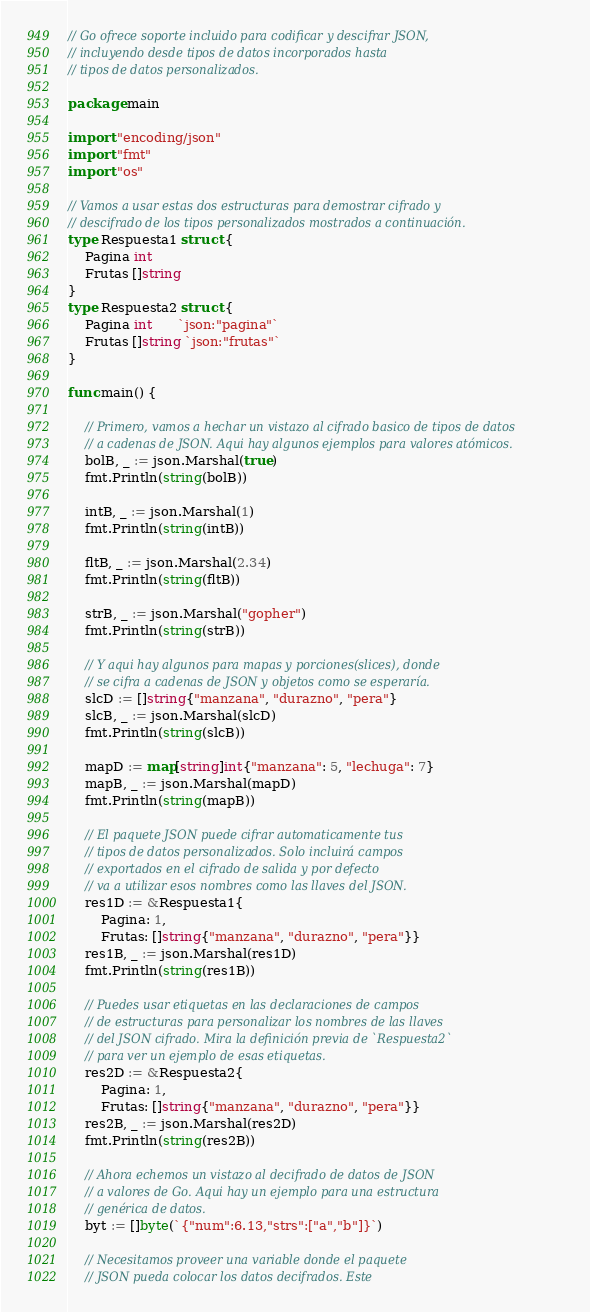<code> <loc_0><loc_0><loc_500><loc_500><_Go_>// Go ofrece soporte incluido para codificar y descifrar JSON,
// incluyendo desde tipos de datos incorporados hasta
// tipos de datos personalizados.

package main

import "encoding/json"
import "fmt"
import "os"

// Vamos a usar estas dos estructuras para demostrar cifrado y
// descifrado de los tipos personalizados mostrados a continuación.
type Respuesta1 struct {
    Pagina int
    Frutas []string
}
type Respuesta2 struct {
    Pagina int      `json:"pagina"`
    Frutas []string `json:"frutas"`
}

func main() {

    // Primero, vamos a hechar un vistazo al cifrado basico de tipos de datos
    // a cadenas de JSON. Aqui hay algunos ejemplos para valores atómicos.
    bolB, _ := json.Marshal(true)
    fmt.Println(string(bolB))

    intB, _ := json.Marshal(1)
    fmt.Println(string(intB))

    fltB, _ := json.Marshal(2.34)
    fmt.Println(string(fltB))

    strB, _ := json.Marshal("gopher")
    fmt.Println(string(strB))

    // Y aqui hay algunos para mapas y porciones(slices), donde
    // se cifra a cadenas de JSON y objetos como se esperaría.
    slcD := []string{"manzana", "durazno", "pera"}
    slcB, _ := json.Marshal(slcD)
    fmt.Println(string(slcB))

    mapD := map[string]int{"manzana": 5, "lechuga": 7}
    mapB, _ := json.Marshal(mapD)
    fmt.Println(string(mapB))

    // El paquete JSON puede cifrar automaticamente tus
    // tipos de datos personalizados. Solo incluirá campos
    // exportados en el cifrado de salida y por defecto
    // va a utilizar esos nombres como las llaves del JSON.
    res1D := &Respuesta1{
        Pagina: 1,
        Frutas: []string{"manzana", "durazno", "pera"}}
    res1B, _ := json.Marshal(res1D)
    fmt.Println(string(res1B))

    // Puedes usar etiquetas en las declaraciones de campos
    // de estructuras para personalizar los nombres de las llaves
    // del JSON cifrado. Mira la definición previa de `Respuesta2`
    // para ver un ejemplo de esas etiquetas.
    res2D := &Respuesta2{
        Pagina: 1,
        Frutas: []string{"manzana", "durazno", "pera"}}
    res2B, _ := json.Marshal(res2D)
    fmt.Println(string(res2B))

    // Ahora echemos un vistazo al decifrado de datos de JSON
    // a valores de Go. Aqui hay un ejemplo para una estructura
    // genérica de datos.
    byt := []byte(`{"num":6.13,"strs":["a","b"]}`)

    // Necesitamos proveer una variable donde el paquete
    // JSON pueda colocar los datos decifrados. Este</code> 